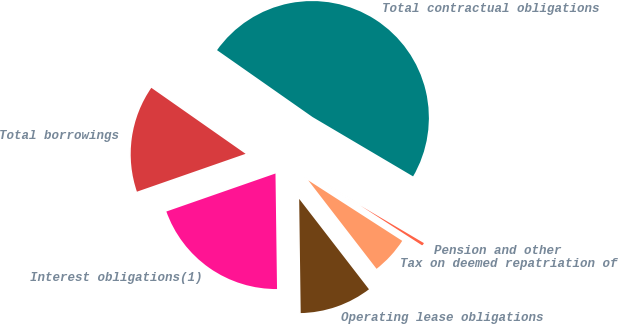Convert chart. <chart><loc_0><loc_0><loc_500><loc_500><pie_chart><fcel>Total borrowings<fcel>Interest obligations(1)<fcel>Operating lease obligations<fcel>Tax on deemed repatriation of<fcel>Pension and other<fcel>Total contractual obligations<nl><fcel>15.06%<fcel>19.88%<fcel>10.25%<fcel>5.43%<fcel>0.62%<fcel>48.77%<nl></chart> 